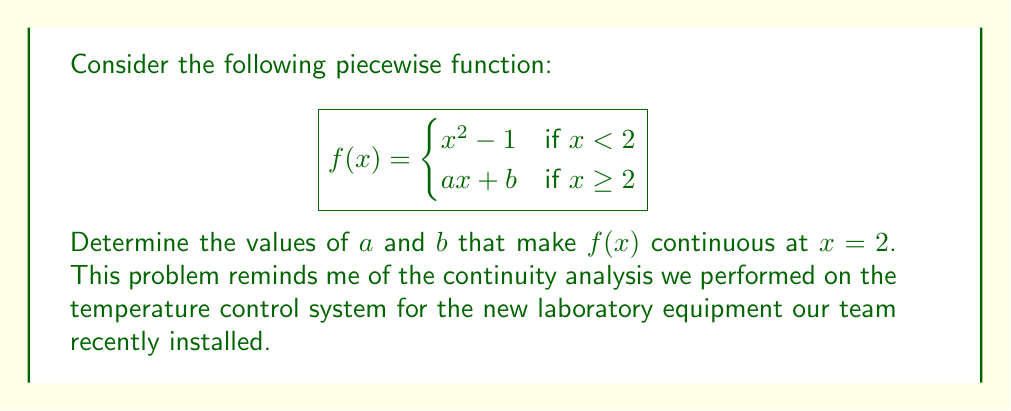Solve this math problem. To determine the continuity of the piecewise function at $x = 2$, we need to ensure that the function satisfies two conditions:

1. The limit of the function as $x$ approaches 2 from both sides must exist and be equal.
2. The function value at $x = 2$ must equal this limit.

Step 1: Calculate the left-hand limit
$$\lim_{x \to 2^-} f(x) = \lim_{x \to 2^-} (x^2 - 1) = 2^2 - 1 = 3$$

Step 2: Calculate the right-hand limit
$$\lim_{x \to 2^+} f(x) = \lim_{x \to 2^+} (ax + b) = 2a + b$$

Step 3: Set the left and right limits equal
$$3 = 2a + b$$

Step 4: Ensure the function value at $x = 2$ equals the limit
$$f(2) = 2a + b = 3$$

Step 5: Solve the system of equations
From steps 3 and 4, we have:
$$2a + b = 3$$

We need another equation to solve for both $a$ and $b$. We can use the fact that the function should be continuous, so the value of the second piece at $x = 2$ should equal the limit we found:

$$f(2) = 2^2 - 1 = 3$$

Therefore, we have:
$$2a + b = 3$$
$$a + b = 2$$

Subtracting the second equation from the first:
$$a = 1$$
Substituting this back into either equation:
$$b = 1$$

Thus, the values that make the function continuous at $x = 2$ are $a = 1$ and $b = 1$.
Answer: $a = 1, b = 1$ 